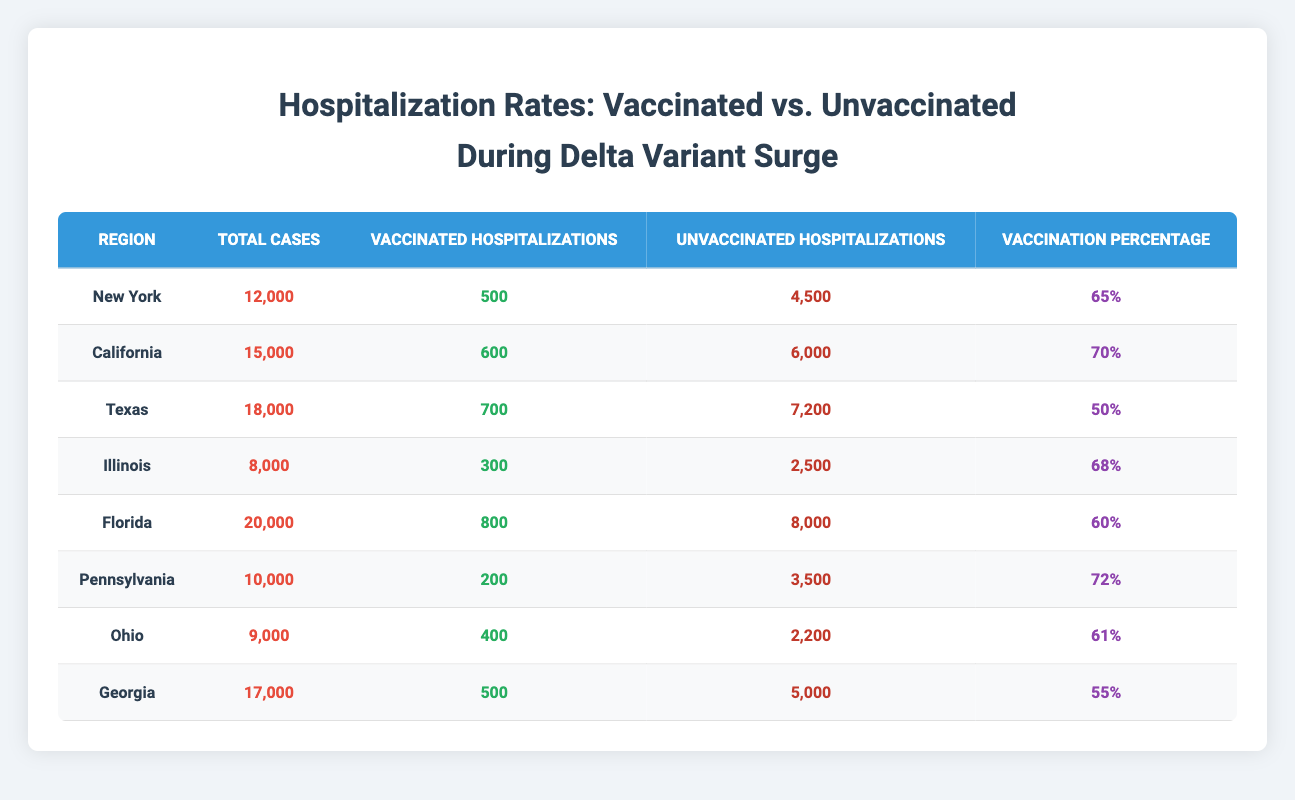What is the total number of hospitalized vaccinated individuals in California? The table shows that California has a total of 600 vaccinated hospitalizations.
Answer: 600 Which region has the highest number of unvaccinated hospitalizations? By comparing the data, Florida has the highest number at 8000 unvaccinated hospitalizations.
Answer: Florida What is the vaccination percentage in Texas? The vaccination percentage for Texas is indicated as 50%.
Answer: 50% Calculate the total number of hospitalizations (vaccinated + unvaccinated) in New York. In New York, there are 500 vaccinated and 4500 unvaccinated hospitalizations. Adding these together gives 500 + 4500 = 5000 total hospitalizations.
Answer: 5000 Is the vaccination percentage in Illinois higher or lower than in Ohio? Illinois has a vaccination percentage of 68% while Ohio has 61%. Since 68% is greater than 61%, Illinois has a higher vaccination percentage than Ohio.
Answer: Higher What is the average hospitalization rate for vaccinated individuals across all regions? The total vaccinated hospitalizations are calculated as 500 + 600 + 700 + 300 + 800 + 200 + 400 + 500 = 3700. There are 8 regions, so the average is 3700 / 8 = 462.5.
Answer: 462.5 In which region is the proportion of vaccinated hospitalizations to total cases highest? The proportion of vaccinated hospitalizations to total cases needs to be calculated. Using the values from each region, we find that Pennsylvania has 200 vaccinated hospitalizations out of 10000 total cases, giving a ratio of 2%. This is higher than other regions.
Answer: Pennsylvania How many more unvaccinated hospitalizations are there in Florida compared to Pennsylvania? Florida has 8000 unvaccinated hospitalizations, while Pennsylvania has 3500. The difference is 8000 - 3500 = 4500 more unvaccinated hospitalizations in Florida.
Answer: 4500 Is it true that the total number of cases in Georgia is less than that in Illinois? Georgia's total cases are 17000, while Illinois has 8000. Since 17000 is greater than 8000, this statement is false.
Answer: False What is the combined number of vaccinated and unvaccinated hospitalizations in Texas? Texas has 700 vaccinated and 7200 unvaccinated hospitalizations. Adding these gives 700 + 7200 = 7900 total hospitalizations.
Answer: 7900 